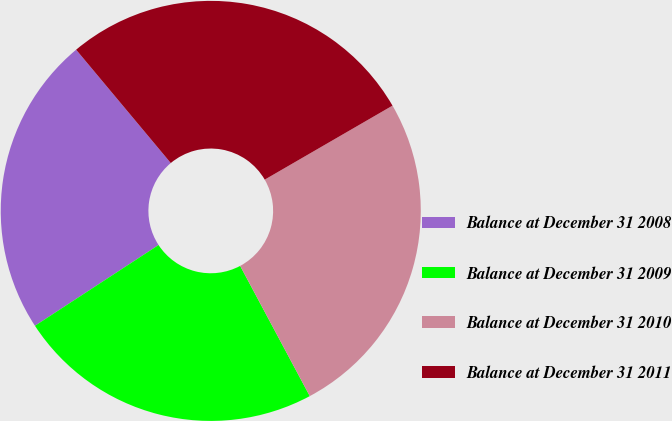Convert chart. <chart><loc_0><loc_0><loc_500><loc_500><pie_chart><fcel>Balance at December 31 2008<fcel>Balance at December 31 2009<fcel>Balance at December 31 2010<fcel>Balance at December 31 2011<nl><fcel>23.14%<fcel>23.6%<fcel>25.54%<fcel>27.72%<nl></chart> 